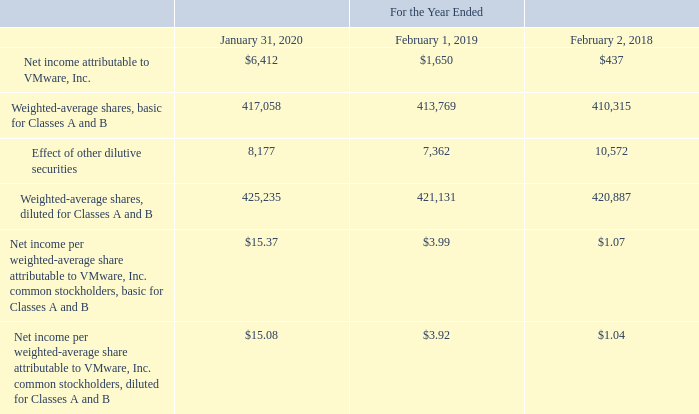H. Net Income Per Share
Basic net income per share is computed by dividing net income by the weighted-average number of common stock outstanding during the period. Diluted net income per share is computed by dividing net income by the weighted-average number of common stock outstanding and potentially dilutive securities outstanding during the period, as calculated using the treasury stock method. Potentially dilutive securities primarily include unvested restricted stock units (“RSUs”), including PSU awards, and stock options, including purchase options under VMware’s employee stock purchase plan, which included Pivotal’s employee stock purchase plan through the date of acquisition. Securities are excluded from the computation of diluted net income per share if their effect would be anti-dilutive. VMware uses the two-class method to calculate net income per share as both classes share the same rights in dividends; therefore, basic and diluted earnings per share are the same for both classes.
The following table sets forth the computations of basic and diluted net income per share during the periods presented (table in millions, except per share amounts and shares in thousands):
Which years does the table provide information for the computations of basic and diluted net income per share? 2020, 2019, 2018. What was the Net income attributable to VMware, Inc. in 2018?
Answer scale should be: million. 437. What was the Weighted-average shares, basic for Classes A and B in 2019?
Answer scale should be: thousand. 413,769. What was the change in the Effect of other dilutive securities between 2018 and 2019?
Answer scale should be: million. 7,362-10,572
Answer: -3210. How many years did the Weighted-average shares, basic for Classes A and B exceed $400,000 million? 2020##2019##2018
Answer: 3. What was the percentage change in the Net income attributable to VMware, Inc. between 2019 and 2020?
Answer scale should be: percent. (6,412-1,650)/1,650
Answer: 288.61. 